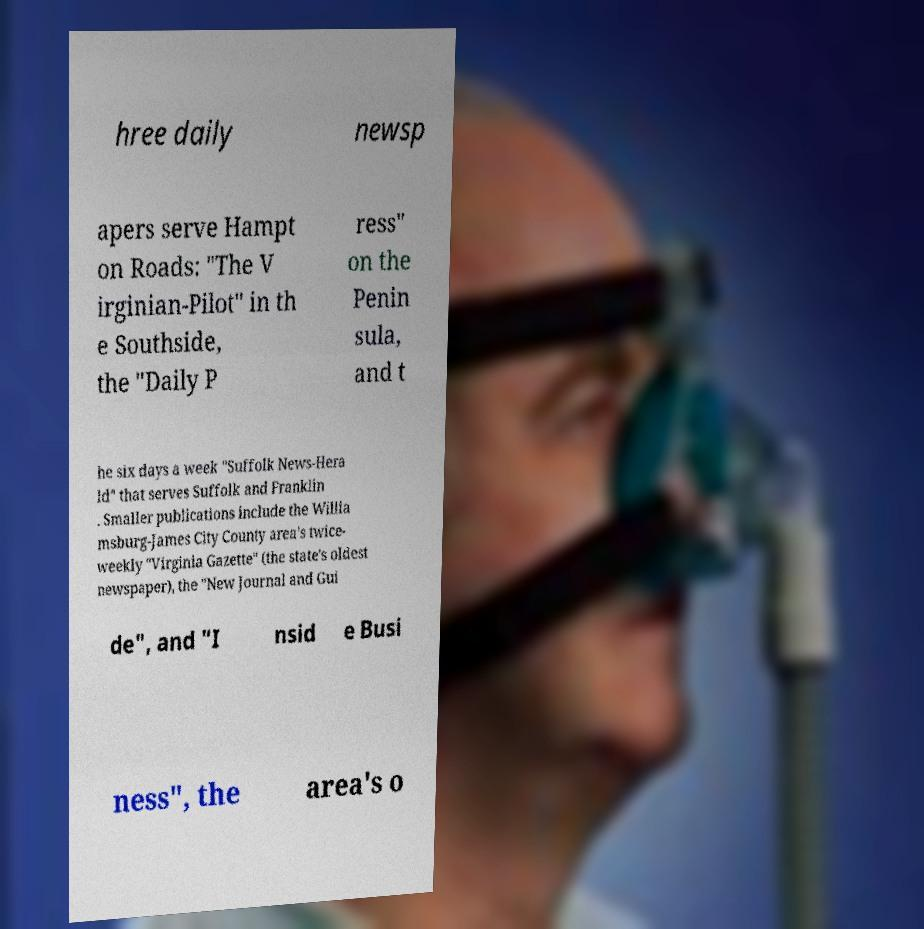What messages or text are displayed in this image? I need them in a readable, typed format. hree daily newsp apers serve Hampt on Roads: "The V irginian-Pilot" in th e Southside, the "Daily P ress" on the Penin sula, and t he six days a week "Suffolk News-Hera ld" that serves Suffolk and Franklin . Smaller publications include the Willia msburg-James City County area's twice- weekly "Virginia Gazette" (the state's oldest newspaper), the "New Journal and Gui de", and "I nsid e Busi ness", the area's o 